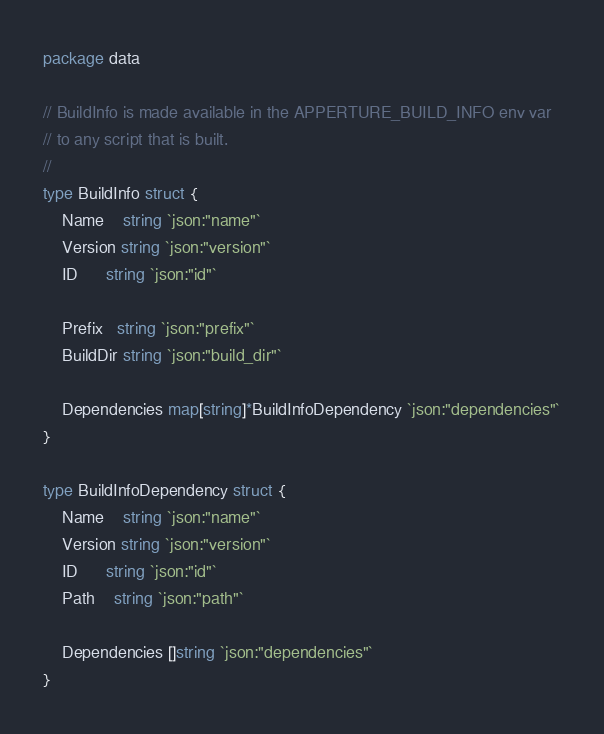<code> <loc_0><loc_0><loc_500><loc_500><_Go_>package data

// BuildInfo is made available in the APPERTURE_BUILD_INFO env var
// to any script that is built.
//
type BuildInfo struct {
	Name    string `json:"name"`
	Version string `json:"version"`
	ID      string `json:"id"`

	Prefix   string `json:"prefix"`
	BuildDir string `json:"build_dir"`

	Dependencies map[string]*BuildInfoDependency `json:"dependencies"`
}

type BuildInfoDependency struct {
	Name    string `json:"name"`
	Version string `json:"version"`
	ID      string `json:"id"`
	Path    string `json:"path"`

	Dependencies []string `json:"dependencies"`
}
</code> 